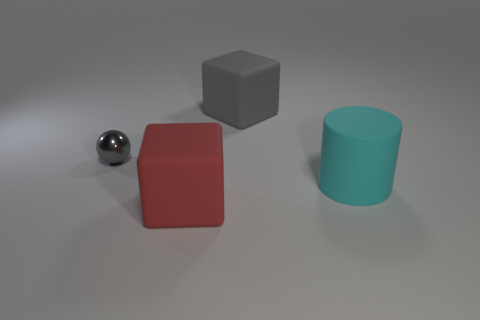Subtract all red cubes. How many cubes are left? 1 Add 3 gray objects. How many objects exist? 7 Subtract 1 spheres. How many spheres are left? 0 Subtract all balls. How many objects are left? 3 Subtract all gray spheres. Subtract all big things. How many objects are left? 0 Add 1 small spheres. How many small spheres are left? 2 Add 3 small cyan cubes. How many small cyan cubes exist? 3 Subtract 0 purple cylinders. How many objects are left? 4 Subtract all blue cylinders. Subtract all gray balls. How many cylinders are left? 1 Subtract all purple cylinders. How many gray blocks are left? 1 